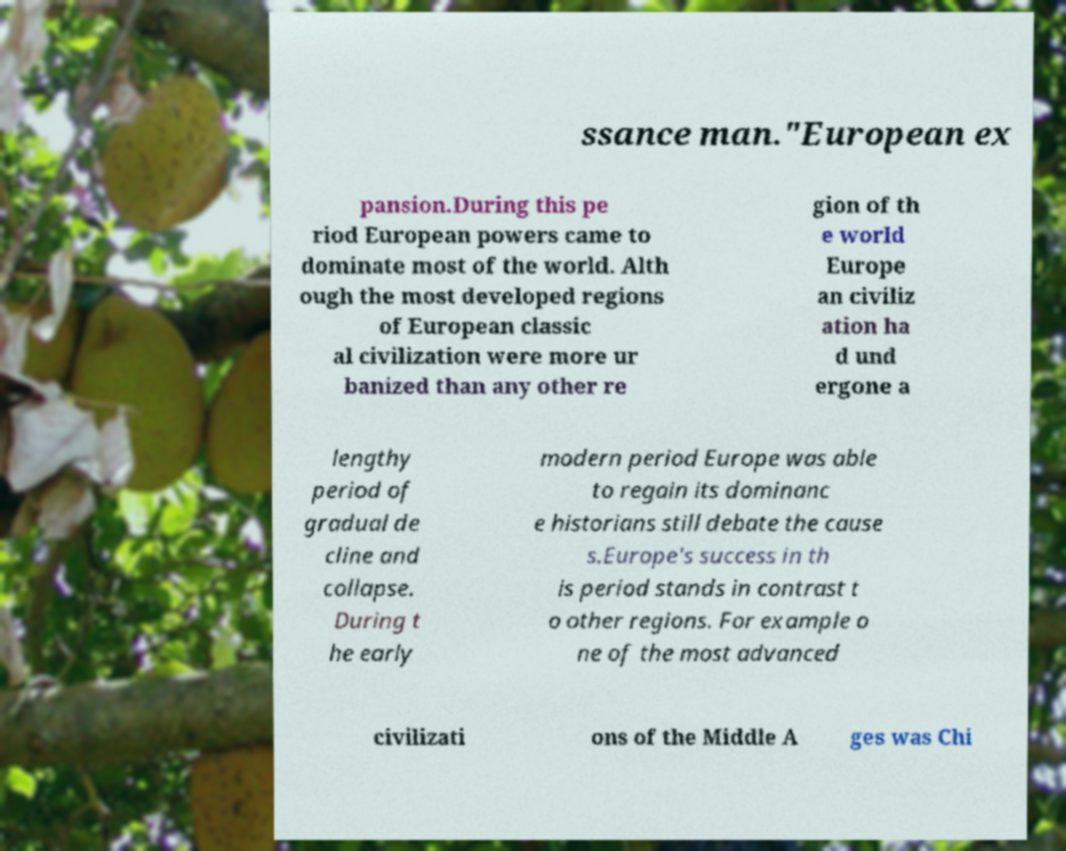For documentation purposes, I need the text within this image transcribed. Could you provide that? ssance man."European ex pansion.During this pe riod European powers came to dominate most of the world. Alth ough the most developed regions of European classic al civilization were more ur banized than any other re gion of th e world Europe an civiliz ation ha d und ergone a lengthy period of gradual de cline and collapse. During t he early modern period Europe was able to regain its dominanc e historians still debate the cause s.Europe's success in th is period stands in contrast t o other regions. For example o ne of the most advanced civilizati ons of the Middle A ges was Chi 